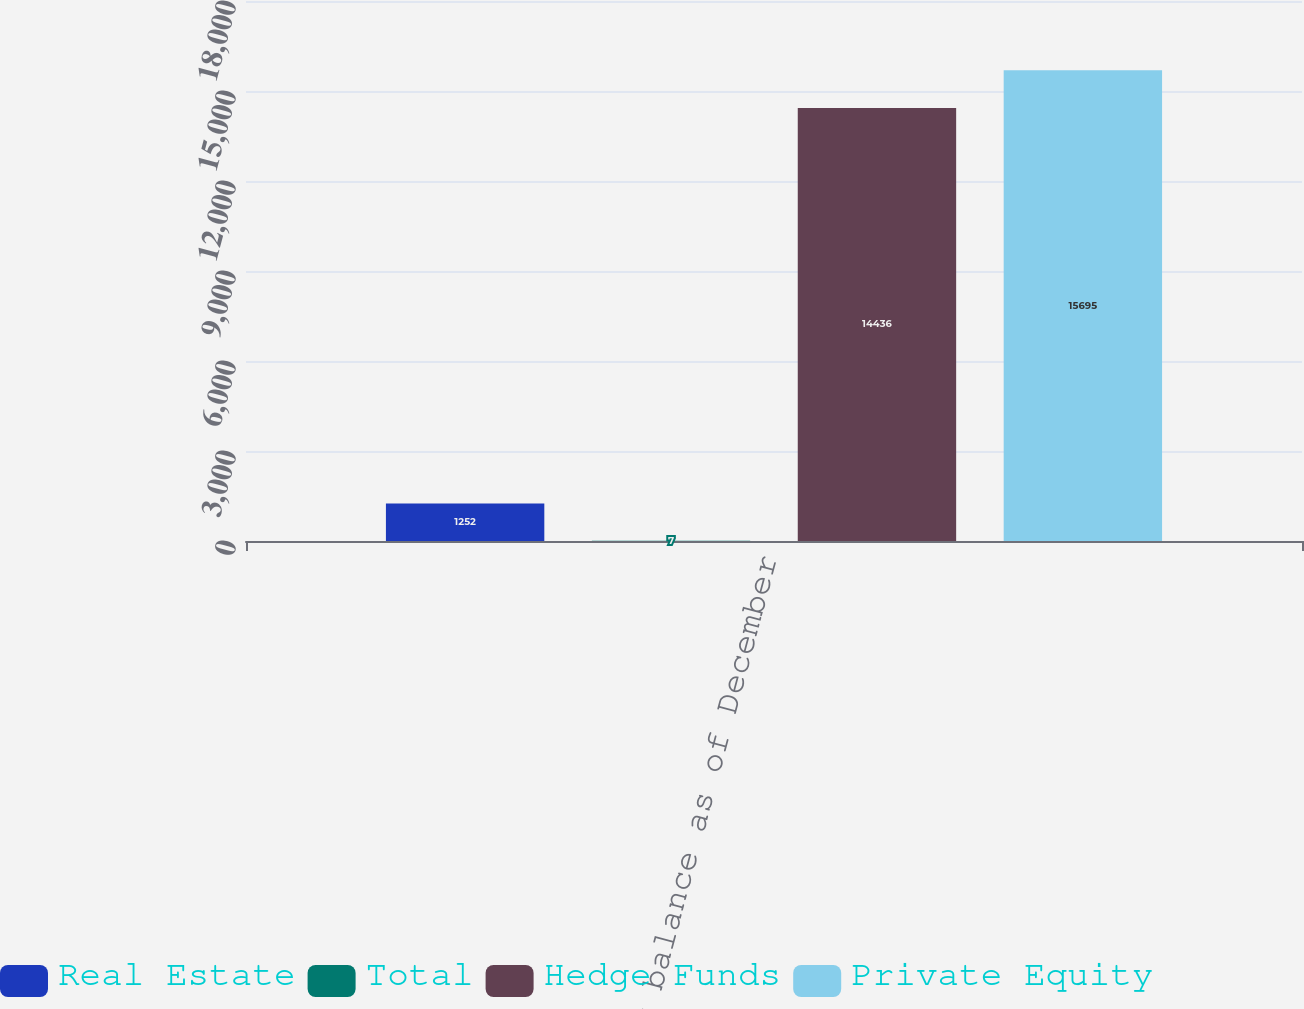Convert chart to OTSL. <chart><loc_0><loc_0><loc_500><loc_500><stacked_bar_chart><ecel><fcel>Ending balance as of December<nl><fcel>Real Estate<fcel>1252<nl><fcel>Total<fcel>7<nl><fcel>Hedge Funds<fcel>14436<nl><fcel>Private Equity<fcel>15695<nl></chart> 